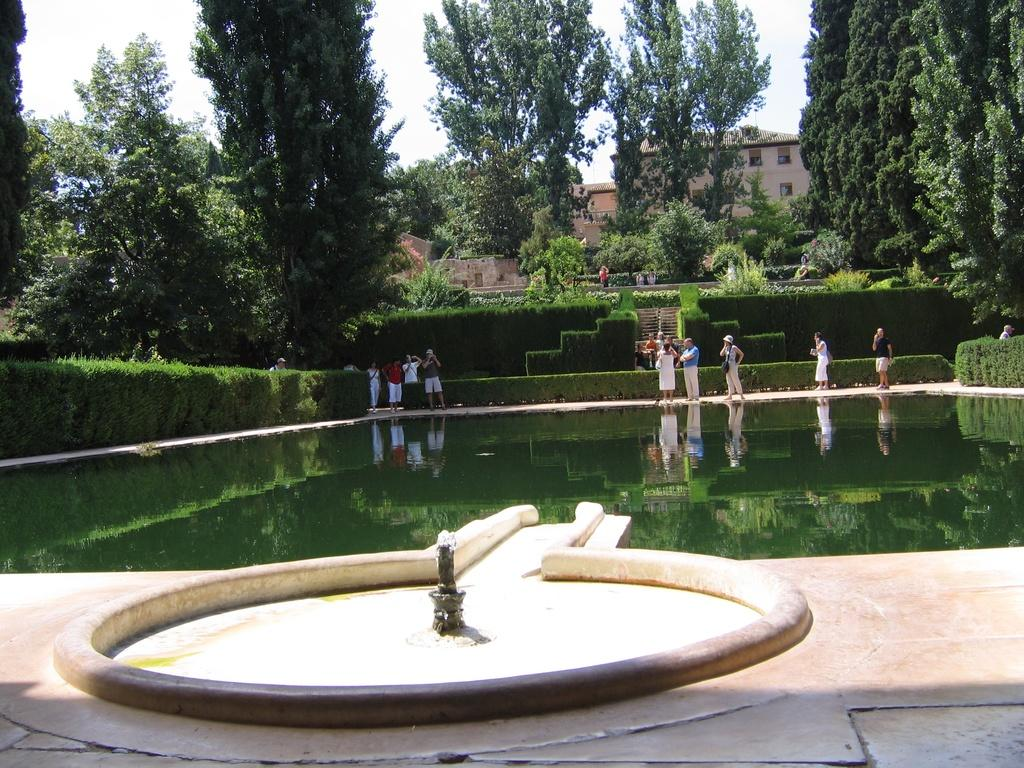What is the main feature in the center of the image? There is water in the center of the image. Are there any living beings present in the image? Yes, there are people in the image. What type of vegetation can be seen in the image? There are bushes and trees in the image. What can be seen in the background of the image? There are buildings and the sky visible in the background of the image. What type of lace can be seen on the people's clothing in the image? There is no lace visible on the people's clothing in the image. Where is the camp located in the image? There is no camp present in the image. 